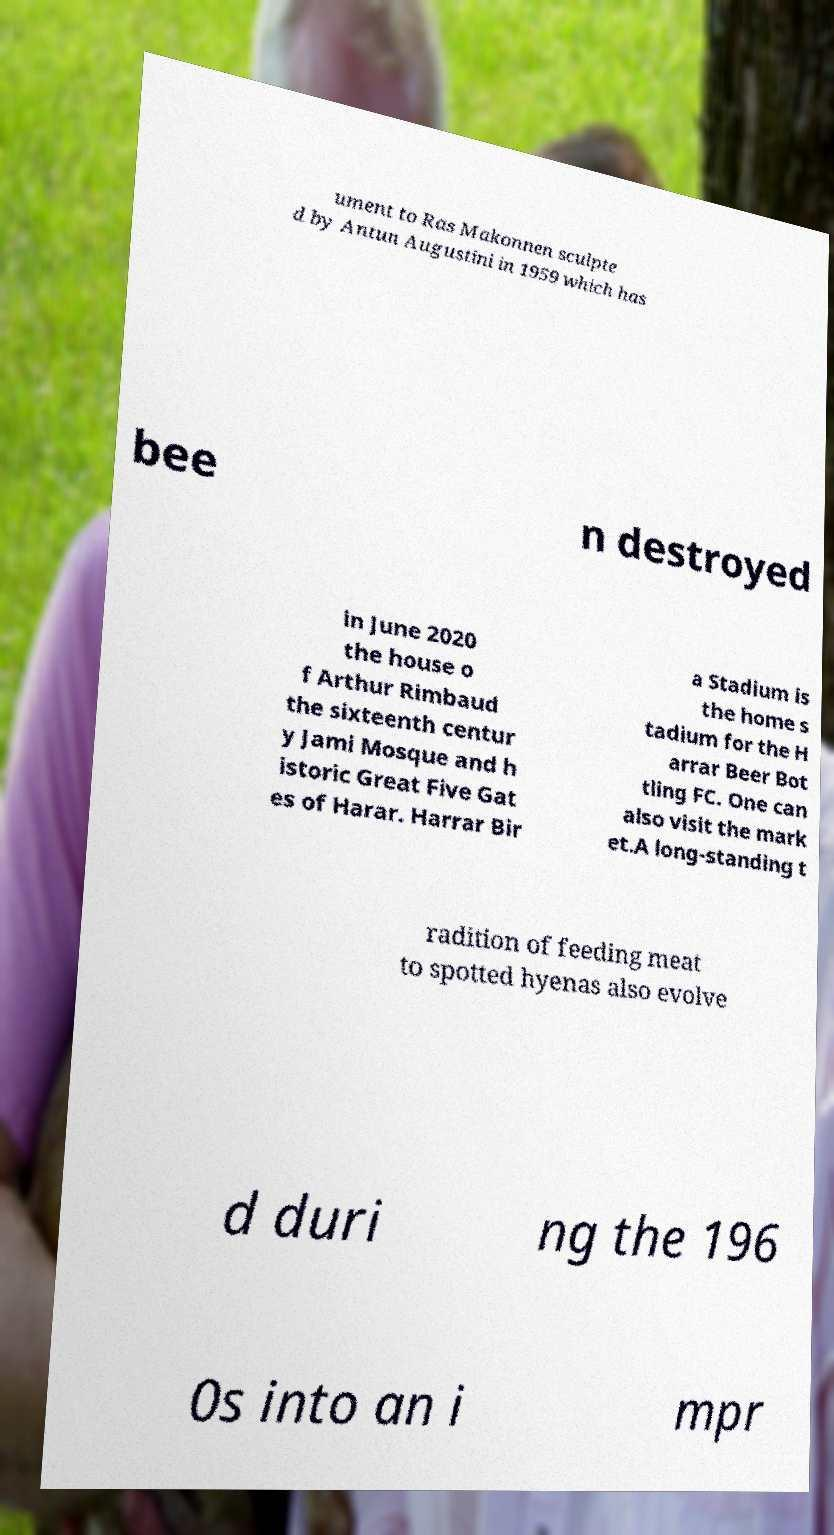Can you read and provide the text displayed in the image?This photo seems to have some interesting text. Can you extract and type it out for me? ument to Ras Makonnen sculpte d by Antun Augustini in 1959 which has bee n destroyed in June 2020 the house o f Arthur Rimbaud the sixteenth centur y Jami Mosque and h istoric Great Five Gat es of Harar. Harrar Bir a Stadium is the home s tadium for the H arrar Beer Bot tling FC. One can also visit the mark et.A long-standing t radition of feeding meat to spotted hyenas also evolve d duri ng the 196 0s into an i mpr 